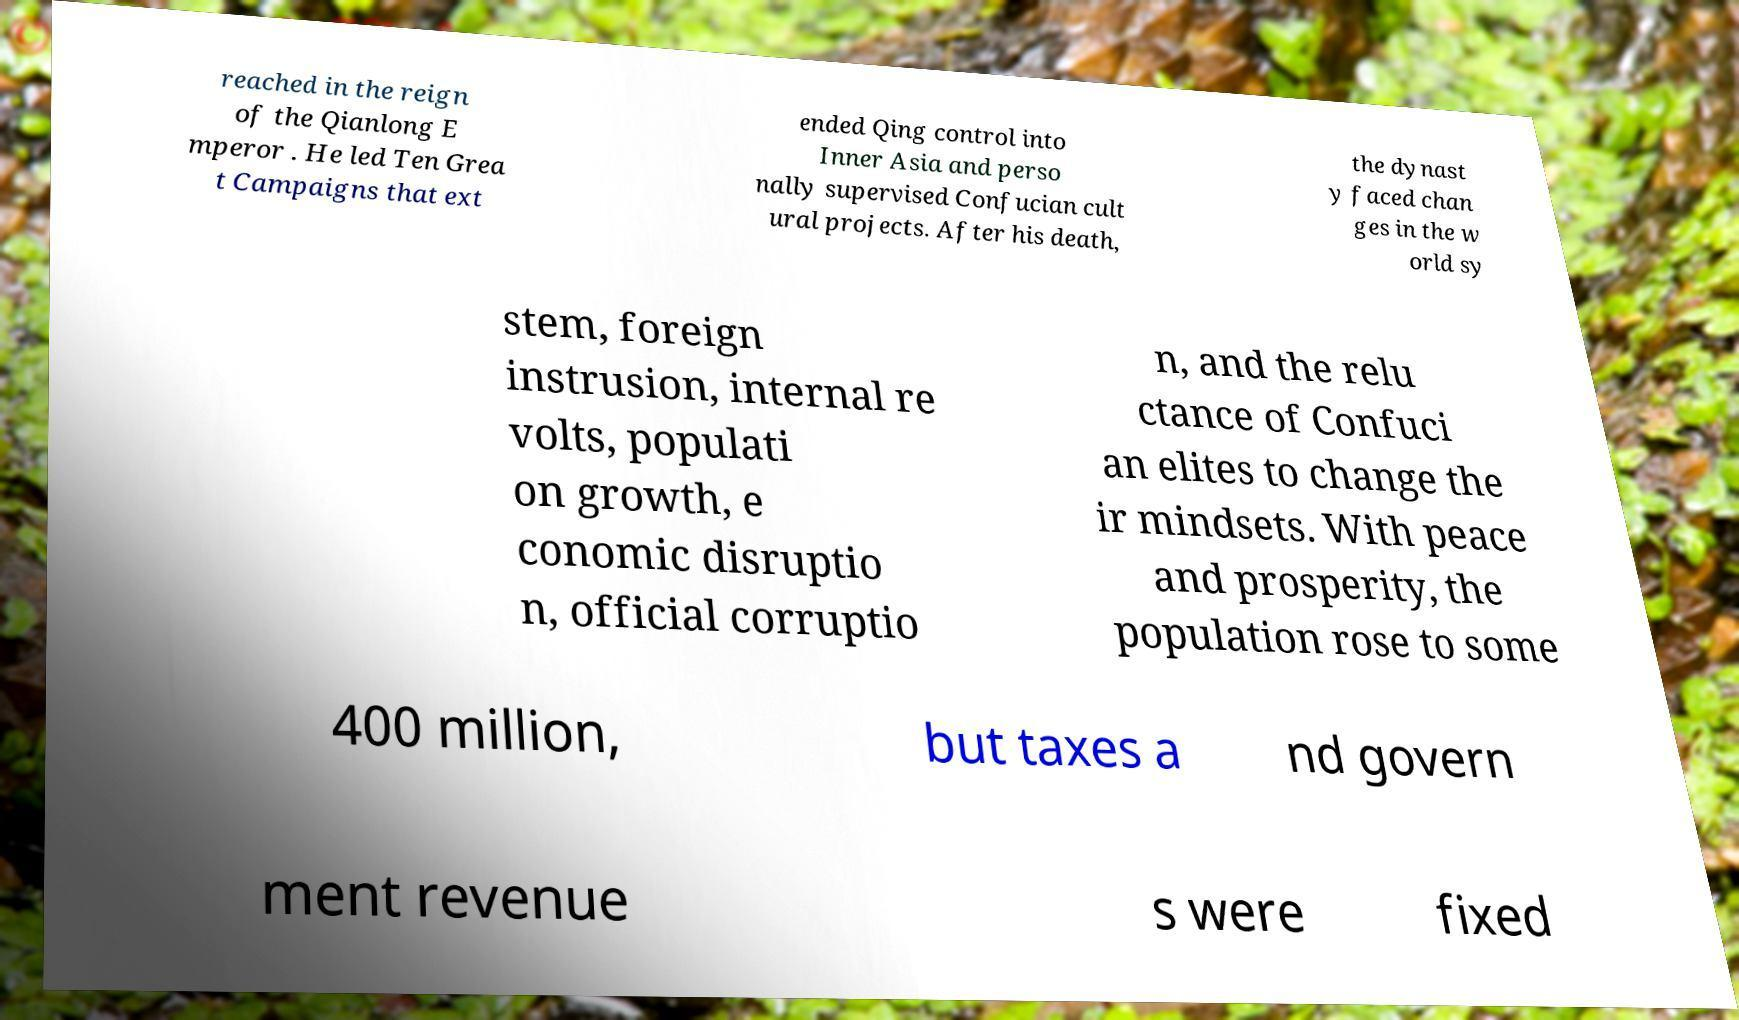Could you assist in decoding the text presented in this image and type it out clearly? reached in the reign of the Qianlong E mperor . He led Ten Grea t Campaigns that ext ended Qing control into Inner Asia and perso nally supervised Confucian cult ural projects. After his death, the dynast y faced chan ges in the w orld sy stem, foreign instrusion, internal re volts, populati on growth, e conomic disruptio n, official corruptio n, and the relu ctance of Confuci an elites to change the ir mindsets. With peace and prosperity, the population rose to some 400 million, but taxes a nd govern ment revenue s were fixed 